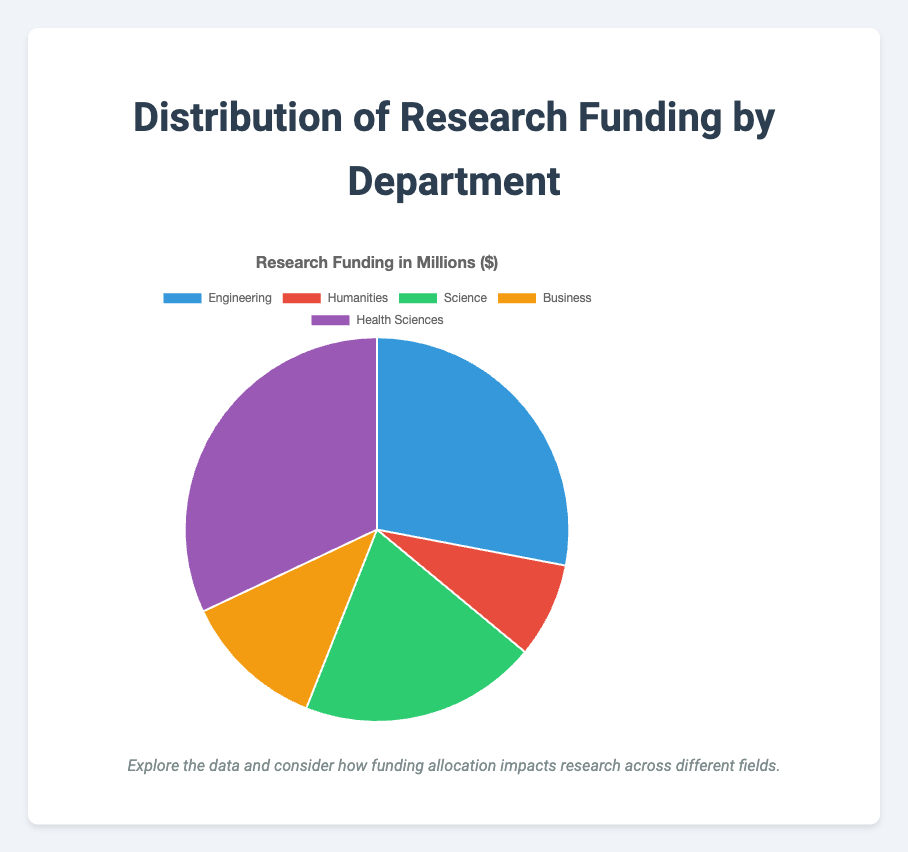what percentage of the research funding goes to the Health Sciences department? To find the percentage of funding for Health Sciences, divide its funding by the total funding and multiply by 100. Total funding = 35 + 10 + 25 + 15 + 40 = 125 million. Percentage for Health Sciences = (40 / 125) * 100 ≈ 32.00%
Answer: 32.00% Which department receives the least amount of funding? Compare the funding amounts for each department. Humanities has the least funding with 10 million dollars.
Answer: Humanities How much more funding does Engineering receive compared to Business? Subtract the funding of Business from Engineering. Engineering: 35 million, Business: 15 million. Difference = 35 - 15 = 20 million dollars.
Answer: 20 million What is the combined funding for the Science and Humanities departments? Add the funding for Science and Humanities. Science: 25 million, Humanities: 10 million. Combined = 25 + 10 = 35 million dollars.
Answer: 35 million What is the average funding among all departments? Sum the funding of all departments and divide by the number of departments. Total funding = 125 million, Number of departments = 5. Average = 125 / 5 = 25 million dollars.
Answer: 25 million Which two departments together receive the same amount of funding as Engineering? Engineering receives 35 million. Check combinations: Humanities + Business = 10 + 15 = 25; Science + Humanities = 25 + 10 = 35. The correct combination is Science and Humanities.
Answer: Science and Humanities What is the ratio of funding between Health Sciences and Engineering? Divide the funding of Health Sciences by Engineering. Health Sciences: 40 million, Engineering: 35 million. Ratio = 40 / 35 = 8:7
Answer: 8:7 If the funding for Business increased by 5 million, how would the new total funding compare to the current funding for Health Sciences? New funding for Business = 15 + 5 = 20 million. Total funding = 35 + 10 + 25 + 20 + 40 = 130 million. Compare new Business funding to Health Sciences (40 million). New total Business funding (20 million) is still less than Health Sciences (40 million)
Answer: Less than Health Sciences What is the funding difference between the highest and the second highest funded departments? Identify highest and second highest funded departments: Health Sciences (40 million), Engineering (35 million). Difference = 40 - 35 = 5 million dollars.
Answer: 5 million 